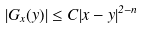<formula> <loc_0><loc_0><loc_500><loc_500>| G _ { x } ( y ) | \leq C | x - y | ^ { 2 - n }</formula> 